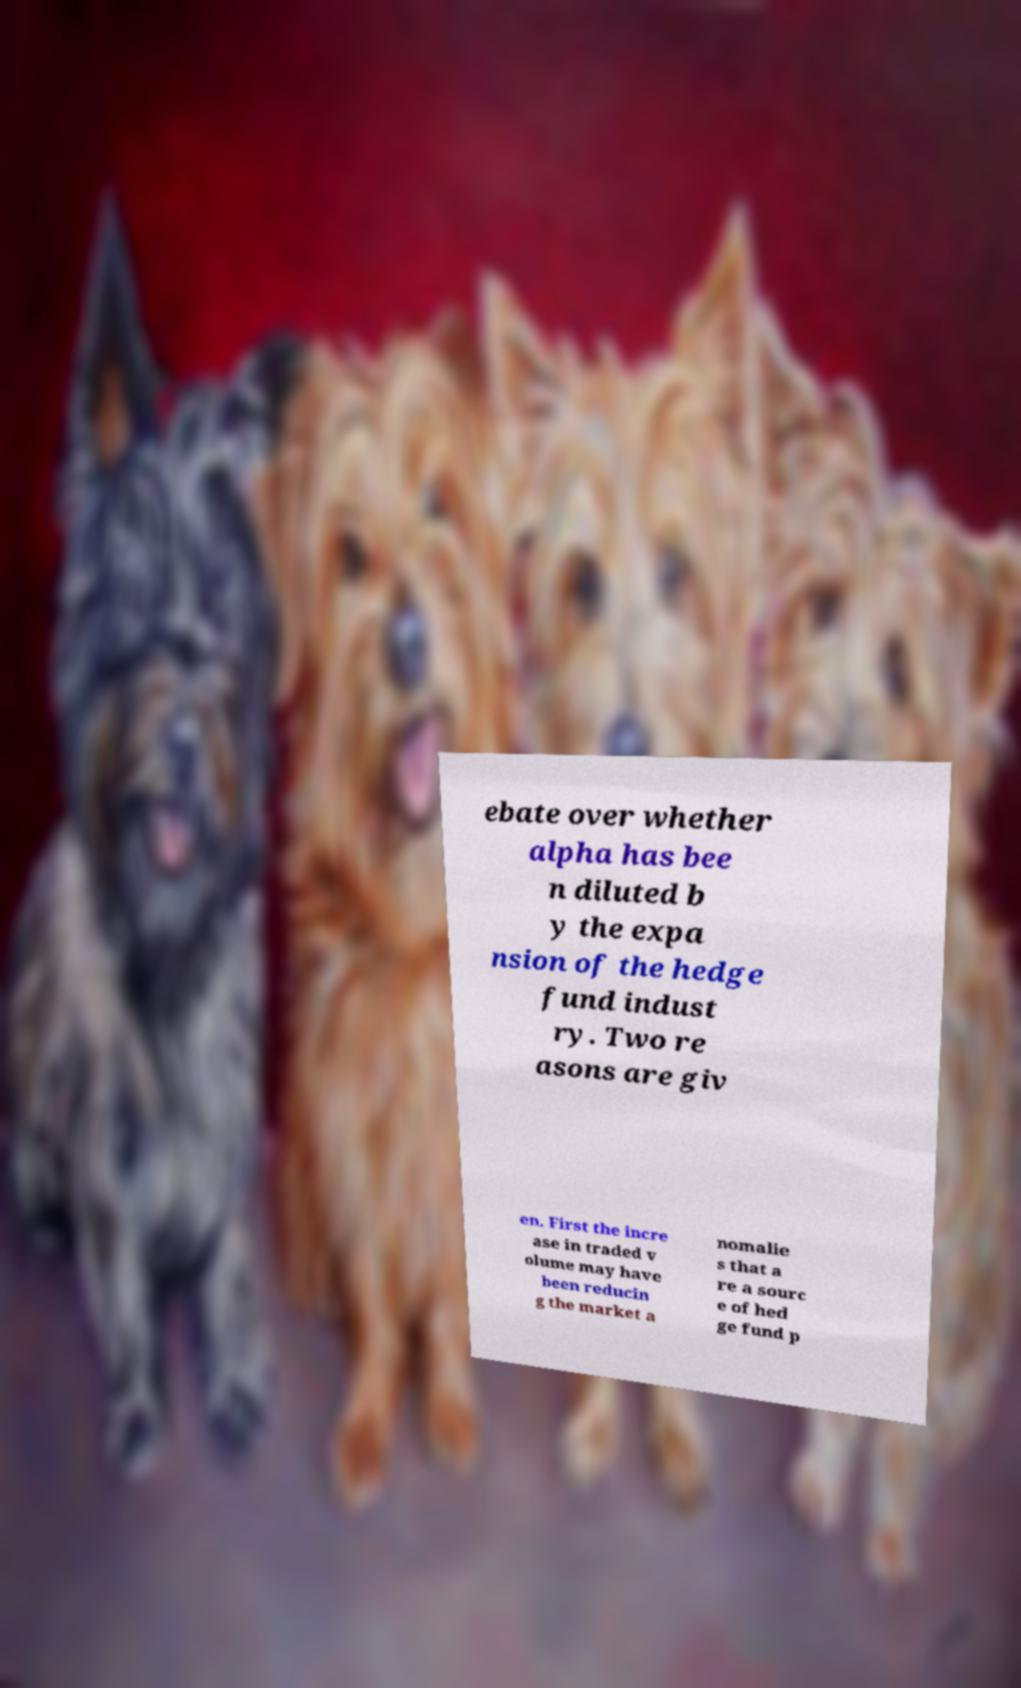Can you read and provide the text displayed in the image?This photo seems to have some interesting text. Can you extract and type it out for me? ebate over whether alpha has bee n diluted b y the expa nsion of the hedge fund indust ry. Two re asons are giv en. First the incre ase in traded v olume may have been reducin g the market a nomalie s that a re a sourc e of hed ge fund p 